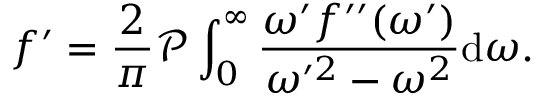<formula> <loc_0><loc_0><loc_500><loc_500>f ^ { \prime } = \frac { 2 } { \pi } \mathcal { P } \int _ { 0 } ^ { \infty } \frac { \omega ^ { \prime } f ^ { \prime \prime } ( \omega ^ { \prime } ) } { \omega ^ { \prime 2 } - \omega ^ { 2 } } d \omega .</formula> 